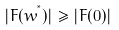<formula> <loc_0><loc_0><loc_500><loc_500>| F ( w ^ { ^ { * } } ) | \geq | F ( 0 ) |</formula> 